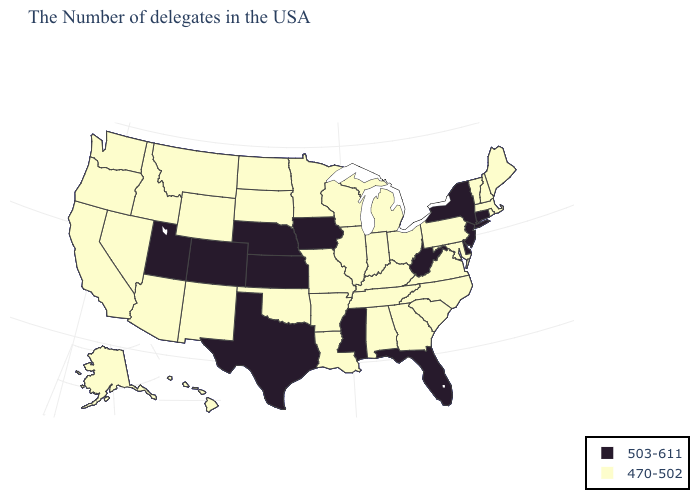Name the states that have a value in the range 503-611?
Short answer required. Connecticut, New York, New Jersey, Delaware, West Virginia, Florida, Mississippi, Iowa, Kansas, Nebraska, Texas, Colorado, Utah. Is the legend a continuous bar?
Answer briefly. No. Name the states that have a value in the range 470-502?
Short answer required. Maine, Massachusetts, Rhode Island, New Hampshire, Vermont, Maryland, Pennsylvania, Virginia, North Carolina, South Carolina, Ohio, Georgia, Michigan, Kentucky, Indiana, Alabama, Tennessee, Wisconsin, Illinois, Louisiana, Missouri, Arkansas, Minnesota, Oklahoma, South Dakota, North Dakota, Wyoming, New Mexico, Montana, Arizona, Idaho, Nevada, California, Washington, Oregon, Alaska, Hawaii. Does the map have missing data?
Be succinct. No. What is the lowest value in the West?
Write a very short answer. 470-502. What is the value of Vermont?
Keep it brief. 470-502. Name the states that have a value in the range 470-502?
Short answer required. Maine, Massachusetts, Rhode Island, New Hampshire, Vermont, Maryland, Pennsylvania, Virginia, North Carolina, South Carolina, Ohio, Georgia, Michigan, Kentucky, Indiana, Alabama, Tennessee, Wisconsin, Illinois, Louisiana, Missouri, Arkansas, Minnesota, Oklahoma, South Dakota, North Dakota, Wyoming, New Mexico, Montana, Arizona, Idaho, Nevada, California, Washington, Oregon, Alaska, Hawaii. How many symbols are there in the legend?
Be succinct. 2. What is the value of Wyoming?
Answer briefly. 470-502. How many symbols are there in the legend?
Be succinct. 2. Name the states that have a value in the range 470-502?
Keep it brief. Maine, Massachusetts, Rhode Island, New Hampshire, Vermont, Maryland, Pennsylvania, Virginia, North Carolina, South Carolina, Ohio, Georgia, Michigan, Kentucky, Indiana, Alabama, Tennessee, Wisconsin, Illinois, Louisiana, Missouri, Arkansas, Minnesota, Oklahoma, South Dakota, North Dakota, Wyoming, New Mexico, Montana, Arizona, Idaho, Nevada, California, Washington, Oregon, Alaska, Hawaii. Name the states that have a value in the range 503-611?
Answer briefly. Connecticut, New York, New Jersey, Delaware, West Virginia, Florida, Mississippi, Iowa, Kansas, Nebraska, Texas, Colorado, Utah. Among the states that border Oregon , which have the lowest value?
Quick response, please. Idaho, Nevada, California, Washington. Does Michigan have the highest value in the MidWest?
Give a very brief answer. No. What is the value of West Virginia?
Be succinct. 503-611. 